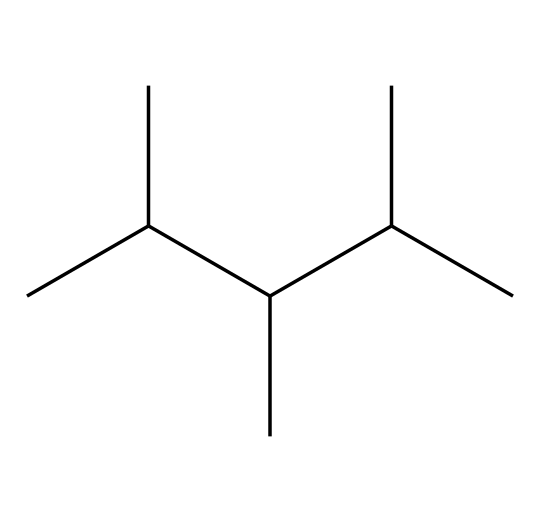What is the total number of carbon atoms in this structure? By analyzing the SMILES representation, each 'C' represents a carbon atom. Count the 'C's, which total to 9.
Answer: 9 How many branched chains are present in this compound? In the SMILES, the branching occurs due to the presence of parentheses indicating branches off the main chain. Here, there are three branches indicated by the structure.
Answer: 3 What type of chemical structure is represented by this SMILES? This SMILES corresponds to a branched aliphatic compound due to the straight-chain with side branches, classified specifically as an alkane.
Answer: alkane What is the degree of saturation of this compound? This compound contains single bonds between carbon atoms and does not exhibit rings or multiple bonds, indicating it is fully saturated. Thus, the degree of saturation is 1 or saturated.
Answer: saturated What is the molecular formula derived from this SMILES representation? Counting the carbon (C) and hydrogen (H) atoms yields C9H20. There are 9 carbon atoms and 20 hydrogen atoms corresponding to the saturated nature of the molecule.
Answer: C9H20 How does the branching in this compound affect its boiling point compared to straight-chain alkanes? The branching reduces the surface area, leading to lower intermolecular forces; hence, this compound’s boiling point will be lower than that of straight-chain alkanes having the same number of carbon atoms.
Answer: lower 